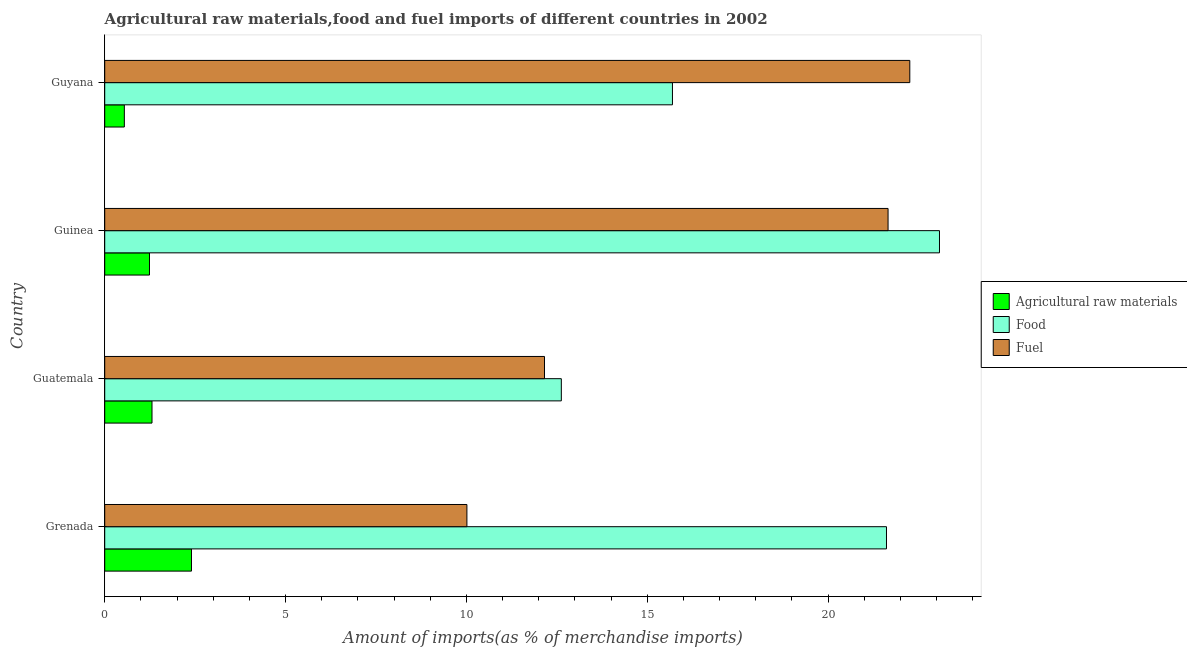How many different coloured bars are there?
Ensure brevity in your answer.  3. Are the number of bars per tick equal to the number of legend labels?
Offer a terse response. Yes. Are the number of bars on each tick of the Y-axis equal?
Your answer should be compact. Yes. How many bars are there on the 2nd tick from the top?
Ensure brevity in your answer.  3. What is the label of the 4th group of bars from the top?
Ensure brevity in your answer.  Grenada. In how many cases, is the number of bars for a given country not equal to the number of legend labels?
Give a very brief answer. 0. What is the percentage of raw materials imports in Guatemala?
Ensure brevity in your answer.  1.31. Across all countries, what is the maximum percentage of raw materials imports?
Provide a short and direct response. 2.4. Across all countries, what is the minimum percentage of fuel imports?
Provide a succinct answer. 10.01. In which country was the percentage of raw materials imports maximum?
Make the answer very short. Grenada. In which country was the percentage of raw materials imports minimum?
Your answer should be compact. Guyana. What is the total percentage of food imports in the graph?
Your response must be concise. 73.01. What is the difference between the percentage of food imports in Grenada and that in Guinea?
Make the answer very short. -1.47. What is the difference between the percentage of fuel imports in Guatemala and the percentage of raw materials imports in Guinea?
Ensure brevity in your answer.  10.92. What is the average percentage of fuel imports per country?
Offer a very short reply. 16.52. What is the difference between the percentage of raw materials imports and percentage of fuel imports in Guyana?
Your answer should be very brief. -21.72. What is the ratio of the percentage of fuel imports in Grenada to that in Guatemala?
Keep it short and to the point. 0.82. What is the difference between the highest and the second highest percentage of food imports?
Provide a short and direct response. 1.47. What is the difference between the highest and the lowest percentage of food imports?
Give a very brief answer. 10.46. In how many countries, is the percentage of fuel imports greater than the average percentage of fuel imports taken over all countries?
Provide a succinct answer. 2. What does the 3rd bar from the top in Guyana represents?
Your answer should be very brief. Agricultural raw materials. What does the 1st bar from the bottom in Guatemala represents?
Give a very brief answer. Agricultural raw materials. Is it the case that in every country, the sum of the percentage of raw materials imports and percentage of food imports is greater than the percentage of fuel imports?
Offer a very short reply. No. How many bars are there?
Your answer should be very brief. 12. Where does the legend appear in the graph?
Provide a short and direct response. Center right. How many legend labels are there?
Your response must be concise. 3. What is the title of the graph?
Make the answer very short. Agricultural raw materials,food and fuel imports of different countries in 2002. Does "Errors" appear as one of the legend labels in the graph?
Offer a very short reply. No. What is the label or title of the X-axis?
Provide a short and direct response. Amount of imports(as % of merchandise imports). What is the label or title of the Y-axis?
Offer a terse response. Country. What is the Amount of imports(as % of merchandise imports) in Agricultural raw materials in Grenada?
Provide a short and direct response. 2.4. What is the Amount of imports(as % of merchandise imports) of Food in Grenada?
Ensure brevity in your answer.  21.61. What is the Amount of imports(as % of merchandise imports) in Fuel in Grenada?
Make the answer very short. 10.01. What is the Amount of imports(as % of merchandise imports) of Agricultural raw materials in Guatemala?
Give a very brief answer. 1.31. What is the Amount of imports(as % of merchandise imports) of Food in Guatemala?
Provide a short and direct response. 12.62. What is the Amount of imports(as % of merchandise imports) of Fuel in Guatemala?
Give a very brief answer. 12.16. What is the Amount of imports(as % of merchandise imports) in Agricultural raw materials in Guinea?
Ensure brevity in your answer.  1.24. What is the Amount of imports(as % of merchandise imports) in Food in Guinea?
Offer a terse response. 23.08. What is the Amount of imports(as % of merchandise imports) in Fuel in Guinea?
Provide a succinct answer. 21.66. What is the Amount of imports(as % of merchandise imports) in Agricultural raw materials in Guyana?
Provide a short and direct response. 0.54. What is the Amount of imports(as % of merchandise imports) in Food in Guyana?
Keep it short and to the point. 15.7. What is the Amount of imports(as % of merchandise imports) of Fuel in Guyana?
Keep it short and to the point. 22.26. Across all countries, what is the maximum Amount of imports(as % of merchandise imports) of Agricultural raw materials?
Ensure brevity in your answer.  2.4. Across all countries, what is the maximum Amount of imports(as % of merchandise imports) of Food?
Make the answer very short. 23.08. Across all countries, what is the maximum Amount of imports(as % of merchandise imports) of Fuel?
Offer a very short reply. 22.26. Across all countries, what is the minimum Amount of imports(as % of merchandise imports) in Agricultural raw materials?
Ensure brevity in your answer.  0.54. Across all countries, what is the minimum Amount of imports(as % of merchandise imports) of Food?
Provide a succinct answer. 12.62. Across all countries, what is the minimum Amount of imports(as % of merchandise imports) of Fuel?
Your answer should be very brief. 10.01. What is the total Amount of imports(as % of merchandise imports) of Agricultural raw materials in the graph?
Give a very brief answer. 5.49. What is the total Amount of imports(as % of merchandise imports) in Food in the graph?
Ensure brevity in your answer.  73.01. What is the total Amount of imports(as % of merchandise imports) in Fuel in the graph?
Your answer should be very brief. 66.09. What is the difference between the Amount of imports(as % of merchandise imports) of Agricultural raw materials in Grenada and that in Guatemala?
Make the answer very short. 1.09. What is the difference between the Amount of imports(as % of merchandise imports) in Food in Grenada and that in Guatemala?
Give a very brief answer. 8.99. What is the difference between the Amount of imports(as % of merchandise imports) in Fuel in Grenada and that in Guatemala?
Ensure brevity in your answer.  -2.15. What is the difference between the Amount of imports(as % of merchandise imports) of Agricultural raw materials in Grenada and that in Guinea?
Provide a short and direct response. 1.16. What is the difference between the Amount of imports(as % of merchandise imports) of Food in Grenada and that in Guinea?
Give a very brief answer. -1.47. What is the difference between the Amount of imports(as % of merchandise imports) in Fuel in Grenada and that in Guinea?
Offer a terse response. -11.64. What is the difference between the Amount of imports(as % of merchandise imports) of Agricultural raw materials in Grenada and that in Guyana?
Your answer should be very brief. 1.86. What is the difference between the Amount of imports(as % of merchandise imports) of Food in Grenada and that in Guyana?
Give a very brief answer. 5.92. What is the difference between the Amount of imports(as % of merchandise imports) in Fuel in Grenada and that in Guyana?
Make the answer very short. -12.25. What is the difference between the Amount of imports(as % of merchandise imports) in Agricultural raw materials in Guatemala and that in Guinea?
Provide a succinct answer. 0.07. What is the difference between the Amount of imports(as % of merchandise imports) in Food in Guatemala and that in Guinea?
Keep it short and to the point. -10.46. What is the difference between the Amount of imports(as % of merchandise imports) in Fuel in Guatemala and that in Guinea?
Ensure brevity in your answer.  -9.5. What is the difference between the Amount of imports(as % of merchandise imports) of Agricultural raw materials in Guatemala and that in Guyana?
Make the answer very short. 0.76. What is the difference between the Amount of imports(as % of merchandise imports) in Food in Guatemala and that in Guyana?
Give a very brief answer. -3.07. What is the difference between the Amount of imports(as % of merchandise imports) of Fuel in Guatemala and that in Guyana?
Ensure brevity in your answer.  -10.1. What is the difference between the Amount of imports(as % of merchandise imports) of Agricultural raw materials in Guinea and that in Guyana?
Give a very brief answer. 0.69. What is the difference between the Amount of imports(as % of merchandise imports) in Food in Guinea and that in Guyana?
Your response must be concise. 7.38. What is the difference between the Amount of imports(as % of merchandise imports) of Fuel in Guinea and that in Guyana?
Keep it short and to the point. -0.6. What is the difference between the Amount of imports(as % of merchandise imports) in Agricultural raw materials in Grenada and the Amount of imports(as % of merchandise imports) in Food in Guatemala?
Offer a terse response. -10.23. What is the difference between the Amount of imports(as % of merchandise imports) in Agricultural raw materials in Grenada and the Amount of imports(as % of merchandise imports) in Fuel in Guatemala?
Your answer should be very brief. -9.76. What is the difference between the Amount of imports(as % of merchandise imports) of Food in Grenada and the Amount of imports(as % of merchandise imports) of Fuel in Guatemala?
Offer a very short reply. 9.46. What is the difference between the Amount of imports(as % of merchandise imports) of Agricultural raw materials in Grenada and the Amount of imports(as % of merchandise imports) of Food in Guinea?
Your response must be concise. -20.68. What is the difference between the Amount of imports(as % of merchandise imports) in Agricultural raw materials in Grenada and the Amount of imports(as % of merchandise imports) in Fuel in Guinea?
Make the answer very short. -19.26. What is the difference between the Amount of imports(as % of merchandise imports) in Food in Grenada and the Amount of imports(as % of merchandise imports) in Fuel in Guinea?
Give a very brief answer. -0.04. What is the difference between the Amount of imports(as % of merchandise imports) of Agricultural raw materials in Grenada and the Amount of imports(as % of merchandise imports) of Food in Guyana?
Your response must be concise. -13.3. What is the difference between the Amount of imports(as % of merchandise imports) of Agricultural raw materials in Grenada and the Amount of imports(as % of merchandise imports) of Fuel in Guyana?
Offer a very short reply. -19.86. What is the difference between the Amount of imports(as % of merchandise imports) of Food in Grenada and the Amount of imports(as % of merchandise imports) of Fuel in Guyana?
Give a very brief answer. -0.64. What is the difference between the Amount of imports(as % of merchandise imports) in Agricultural raw materials in Guatemala and the Amount of imports(as % of merchandise imports) in Food in Guinea?
Your answer should be compact. -21.77. What is the difference between the Amount of imports(as % of merchandise imports) of Agricultural raw materials in Guatemala and the Amount of imports(as % of merchandise imports) of Fuel in Guinea?
Offer a terse response. -20.35. What is the difference between the Amount of imports(as % of merchandise imports) in Food in Guatemala and the Amount of imports(as % of merchandise imports) in Fuel in Guinea?
Keep it short and to the point. -9.03. What is the difference between the Amount of imports(as % of merchandise imports) in Agricultural raw materials in Guatemala and the Amount of imports(as % of merchandise imports) in Food in Guyana?
Keep it short and to the point. -14.39. What is the difference between the Amount of imports(as % of merchandise imports) in Agricultural raw materials in Guatemala and the Amount of imports(as % of merchandise imports) in Fuel in Guyana?
Offer a very short reply. -20.95. What is the difference between the Amount of imports(as % of merchandise imports) of Food in Guatemala and the Amount of imports(as % of merchandise imports) of Fuel in Guyana?
Offer a very short reply. -9.63. What is the difference between the Amount of imports(as % of merchandise imports) in Agricultural raw materials in Guinea and the Amount of imports(as % of merchandise imports) in Food in Guyana?
Give a very brief answer. -14.46. What is the difference between the Amount of imports(as % of merchandise imports) in Agricultural raw materials in Guinea and the Amount of imports(as % of merchandise imports) in Fuel in Guyana?
Your response must be concise. -21.02. What is the difference between the Amount of imports(as % of merchandise imports) of Food in Guinea and the Amount of imports(as % of merchandise imports) of Fuel in Guyana?
Provide a short and direct response. 0.82. What is the average Amount of imports(as % of merchandise imports) in Agricultural raw materials per country?
Offer a very short reply. 1.37. What is the average Amount of imports(as % of merchandise imports) of Food per country?
Offer a very short reply. 18.25. What is the average Amount of imports(as % of merchandise imports) of Fuel per country?
Make the answer very short. 16.52. What is the difference between the Amount of imports(as % of merchandise imports) of Agricultural raw materials and Amount of imports(as % of merchandise imports) of Food in Grenada?
Your response must be concise. -19.22. What is the difference between the Amount of imports(as % of merchandise imports) of Agricultural raw materials and Amount of imports(as % of merchandise imports) of Fuel in Grenada?
Offer a very short reply. -7.62. What is the difference between the Amount of imports(as % of merchandise imports) in Food and Amount of imports(as % of merchandise imports) in Fuel in Grenada?
Offer a very short reply. 11.6. What is the difference between the Amount of imports(as % of merchandise imports) of Agricultural raw materials and Amount of imports(as % of merchandise imports) of Food in Guatemala?
Your response must be concise. -11.32. What is the difference between the Amount of imports(as % of merchandise imports) of Agricultural raw materials and Amount of imports(as % of merchandise imports) of Fuel in Guatemala?
Ensure brevity in your answer.  -10.85. What is the difference between the Amount of imports(as % of merchandise imports) in Food and Amount of imports(as % of merchandise imports) in Fuel in Guatemala?
Provide a short and direct response. 0.47. What is the difference between the Amount of imports(as % of merchandise imports) of Agricultural raw materials and Amount of imports(as % of merchandise imports) of Food in Guinea?
Your response must be concise. -21.84. What is the difference between the Amount of imports(as % of merchandise imports) of Agricultural raw materials and Amount of imports(as % of merchandise imports) of Fuel in Guinea?
Offer a very short reply. -20.42. What is the difference between the Amount of imports(as % of merchandise imports) in Food and Amount of imports(as % of merchandise imports) in Fuel in Guinea?
Give a very brief answer. 1.42. What is the difference between the Amount of imports(as % of merchandise imports) of Agricultural raw materials and Amount of imports(as % of merchandise imports) of Food in Guyana?
Offer a terse response. -15.15. What is the difference between the Amount of imports(as % of merchandise imports) of Agricultural raw materials and Amount of imports(as % of merchandise imports) of Fuel in Guyana?
Keep it short and to the point. -21.72. What is the difference between the Amount of imports(as % of merchandise imports) in Food and Amount of imports(as % of merchandise imports) in Fuel in Guyana?
Give a very brief answer. -6.56. What is the ratio of the Amount of imports(as % of merchandise imports) in Agricultural raw materials in Grenada to that in Guatemala?
Keep it short and to the point. 1.83. What is the ratio of the Amount of imports(as % of merchandise imports) of Food in Grenada to that in Guatemala?
Give a very brief answer. 1.71. What is the ratio of the Amount of imports(as % of merchandise imports) in Fuel in Grenada to that in Guatemala?
Keep it short and to the point. 0.82. What is the ratio of the Amount of imports(as % of merchandise imports) of Agricultural raw materials in Grenada to that in Guinea?
Your answer should be compact. 1.94. What is the ratio of the Amount of imports(as % of merchandise imports) of Food in Grenada to that in Guinea?
Your response must be concise. 0.94. What is the ratio of the Amount of imports(as % of merchandise imports) of Fuel in Grenada to that in Guinea?
Give a very brief answer. 0.46. What is the ratio of the Amount of imports(as % of merchandise imports) of Agricultural raw materials in Grenada to that in Guyana?
Make the answer very short. 4.42. What is the ratio of the Amount of imports(as % of merchandise imports) of Food in Grenada to that in Guyana?
Provide a short and direct response. 1.38. What is the ratio of the Amount of imports(as % of merchandise imports) of Fuel in Grenada to that in Guyana?
Your answer should be very brief. 0.45. What is the ratio of the Amount of imports(as % of merchandise imports) of Agricultural raw materials in Guatemala to that in Guinea?
Provide a succinct answer. 1.06. What is the ratio of the Amount of imports(as % of merchandise imports) of Food in Guatemala to that in Guinea?
Ensure brevity in your answer.  0.55. What is the ratio of the Amount of imports(as % of merchandise imports) of Fuel in Guatemala to that in Guinea?
Provide a short and direct response. 0.56. What is the ratio of the Amount of imports(as % of merchandise imports) in Agricultural raw materials in Guatemala to that in Guyana?
Make the answer very short. 2.41. What is the ratio of the Amount of imports(as % of merchandise imports) of Food in Guatemala to that in Guyana?
Your answer should be very brief. 0.8. What is the ratio of the Amount of imports(as % of merchandise imports) of Fuel in Guatemala to that in Guyana?
Provide a succinct answer. 0.55. What is the ratio of the Amount of imports(as % of merchandise imports) of Agricultural raw materials in Guinea to that in Guyana?
Give a very brief answer. 2.28. What is the ratio of the Amount of imports(as % of merchandise imports) in Food in Guinea to that in Guyana?
Offer a terse response. 1.47. What is the difference between the highest and the second highest Amount of imports(as % of merchandise imports) of Agricultural raw materials?
Your answer should be very brief. 1.09. What is the difference between the highest and the second highest Amount of imports(as % of merchandise imports) of Food?
Keep it short and to the point. 1.47. What is the difference between the highest and the second highest Amount of imports(as % of merchandise imports) of Fuel?
Provide a succinct answer. 0.6. What is the difference between the highest and the lowest Amount of imports(as % of merchandise imports) of Agricultural raw materials?
Make the answer very short. 1.86. What is the difference between the highest and the lowest Amount of imports(as % of merchandise imports) in Food?
Your answer should be very brief. 10.46. What is the difference between the highest and the lowest Amount of imports(as % of merchandise imports) of Fuel?
Ensure brevity in your answer.  12.25. 